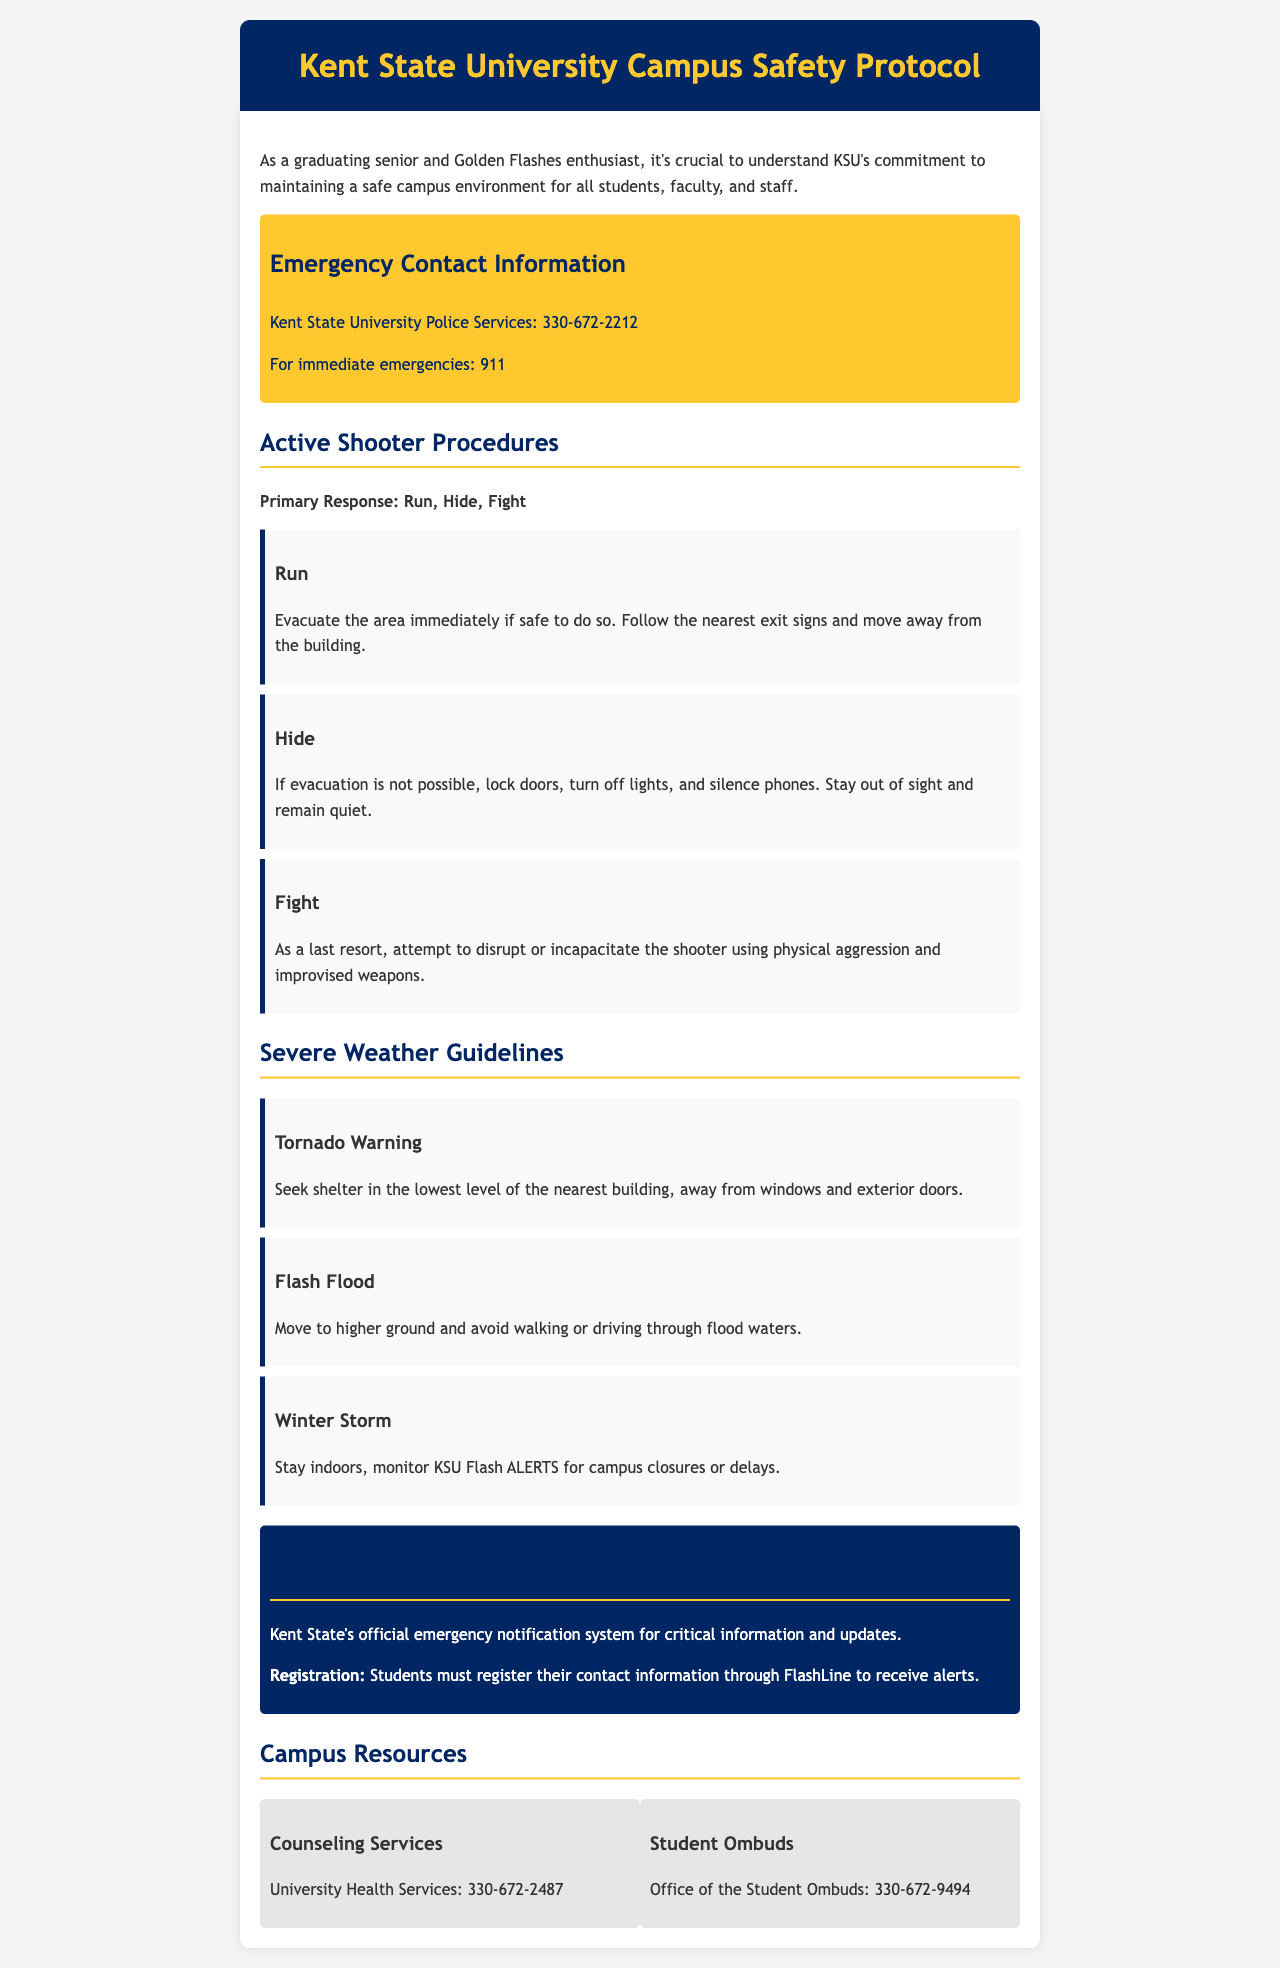what is the emergency contact number for Kent State University Police Services? The document provides specific emergency contact information, stating the number for Kent State University Police Services is 330-672-2212.
Answer: 330-672-2212 what is the first step in the active shooter procedures? The active shooter procedures begin with the primary response of "Run," which is described as evacuating the area if safe to do so.
Answer: Run what should you do during a tornado warning? The severe weather guidelines specify that during a tornado warning, you should seek shelter in the lowest level of the nearest building, away from windows and exterior doors.
Answer: Seek shelter in the lowest level how can students register for Flash ALERTS? The document states that students must register their contact information through FlashLine to receive alerts from the emergency notification system.
Answer: Through FlashLine what is the number for University Health Services? The document lists the number for University Health Services as 330-672-2487.
Answer: 330-672-2487 what is the last resort action in active shooter procedures? According to the active shooter procedures, if neither running nor hiding is possible, the last resort is to attempt to disrupt or incapacitate the shooter.
Answer: Fight where should you move during a flash flood? The severe weather guidelines indicate that during a flash flood, you should move to higher ground and avoid flood waters.
Answer: Higher ground which office can students contact for ombud services? The document identifies the Office of the Student Ombuds as a resource available to students, with the contact number being 330-672-9494.
Answer: Office of the Student Ombuds 